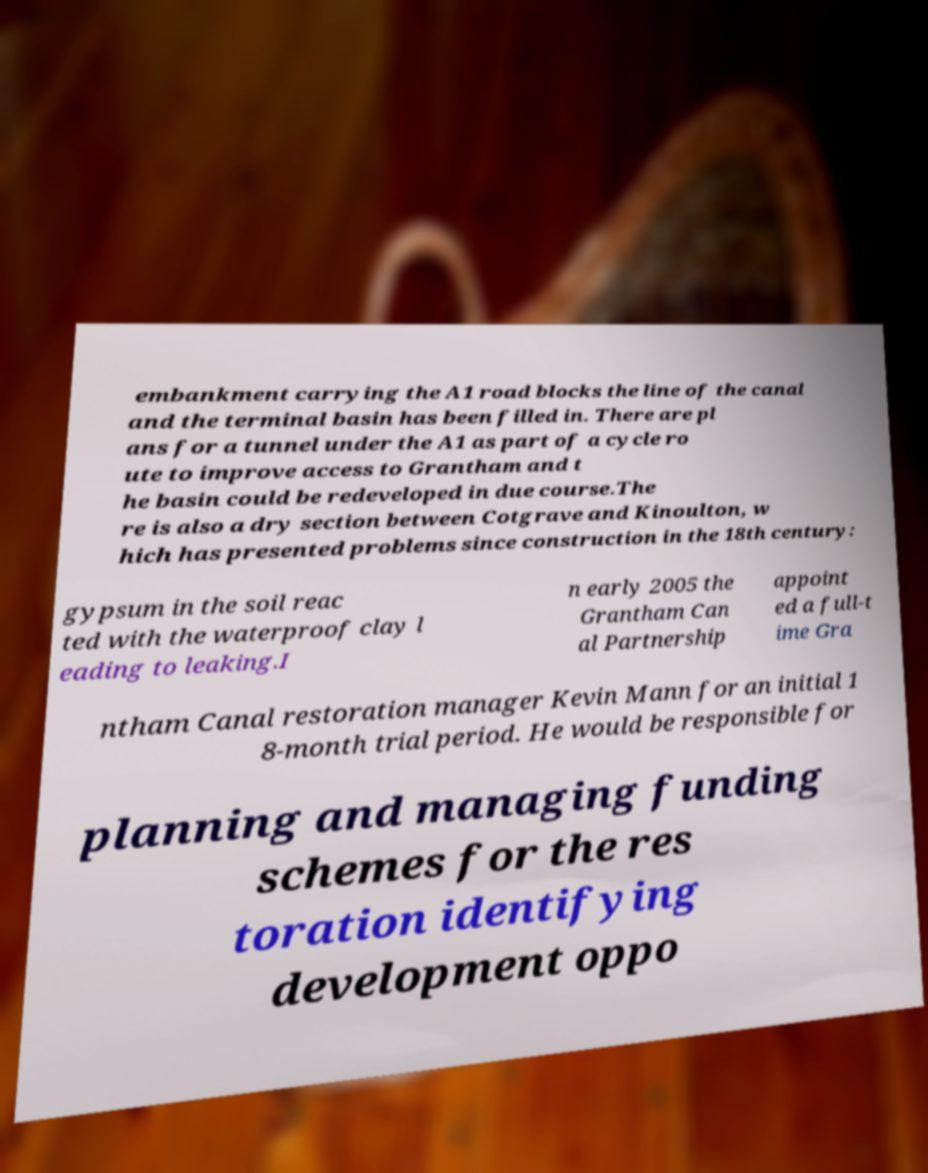Please read and relay the text visible in this image. What does it say? embankment carrying the A1 road blocks the line of the canal and the terminal basin has been filled in. There are pl ans for a tunnel under the A1 as part of a cycle ro ute to improve access to Grantham and t he basin could be redeveloped in due course.The re is also a dry section between Cotgrave and Kinoulton, w hich has presented problems since construction in the 18th century: gypsum in the soil reac ted with the waterproof clay l eading to leaking.I n early 2005 the Grantham Can al Partnership appoint ed a full-t ime Gra ntham Canal restoration manager Kevin Mann for an initial 1 8-month trial period. He would be responsible for planning and managing funding schemes for the res toration identifying development oppo 